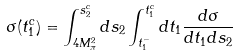<formula> <loc_0><loc_0><loc_500><loc_500>\sigma ( t _ { 1 } ^ { c } ) = \int _ { 4 M _ { \pi } ^ { 2 } } ^ { s _ { 2 } ^ { c } } d s _ { 2 } \int _ { t _ { 1 } ^ { - } } ^ { t _ { 1 } ^ { c } } d t _ { 1 } \frac { d \sigma } { d t _ { 1 } d s _ { 2 } }</formula> 